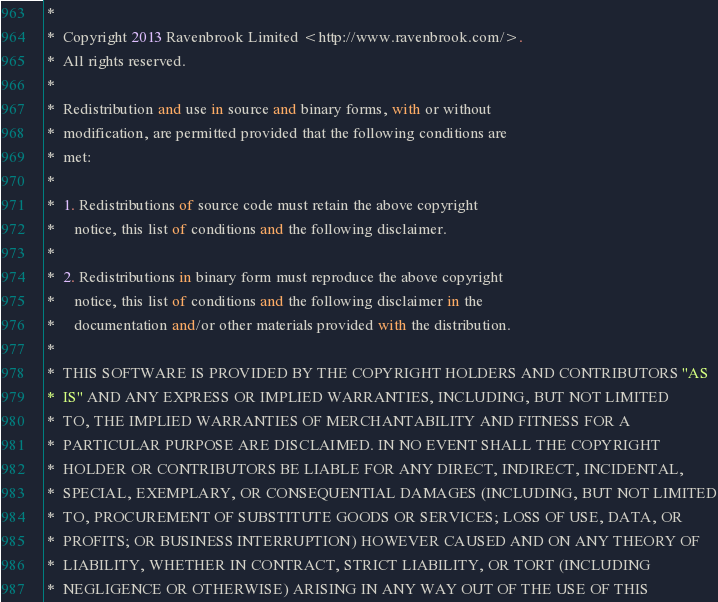Convert code to text. <code><loc_0><loc_0><loc_500><loc_500><_SML_> *
 *  Copyright 2013 Ravenbrook Limited <http://www.ravenbrook.com/>.
 *  All rights reserved.
 *  
 *  Redistribution and use in source and binary forms, with or without
 *  modification, are permitted provided that the following conditions are
 *  met:
 *  
 *  1. Redistributions of source code must retain the above copyright
 *     notice, this list of conditions and the following disclaimer.
 *  
 *  2. Redistributions in binary form must reproduce the above copyright
 *     notice, this list of conditions and the following disclaimer in the
 *     documentation and/or other materials provided with the distribution.
 *  
 *  THIS SOFTWARE IS PROVIDED BY THE COPYRIGHT HOLDERS AND CONTRIBUTORS "AS
 *  IS" AND ANY EXPRESS OR IMPLIED WARRANTIES, INCLUDING, BUT NOT LIMITED
 *  TO, THE IMPLIED WARRANTIES OF MERCHANTABILITY AND FITNESS FOR A
 *  PARTICULAR PURPOSE ARE DISCLAIMED. IN NO EVENT SHALL THE COPYRIGHT
 *  HOLDER OR CONTRIBUTORS BE LIABLE FOR ANY DIRECT, INDIRECT, INCIDENTAL,
 *  SPECIAL, EXEMPLARY, OR CONSEQUENTIAL DAMAGES (INCLUDING, BUT NOT LIMITED
 *  TO, PROCUREMENT OF SUBSTITUTE GOODS OR SERVICES; LOSS OF USE, DATA, OR
 *  PROFITS; OR BUSINESS INTERRUPTION) HOWEVER CAUSED AND ON ANY THEORY OF
 *  LIABILITY, WHETHER IN CONTRACT, STRICT LIABILITY, OR TORT (INCLUDING
 *  NEGLIGENCE OR OTHERWISE) ARISING IN ANY WAY OUT OF THE USE OF THIS</code> 